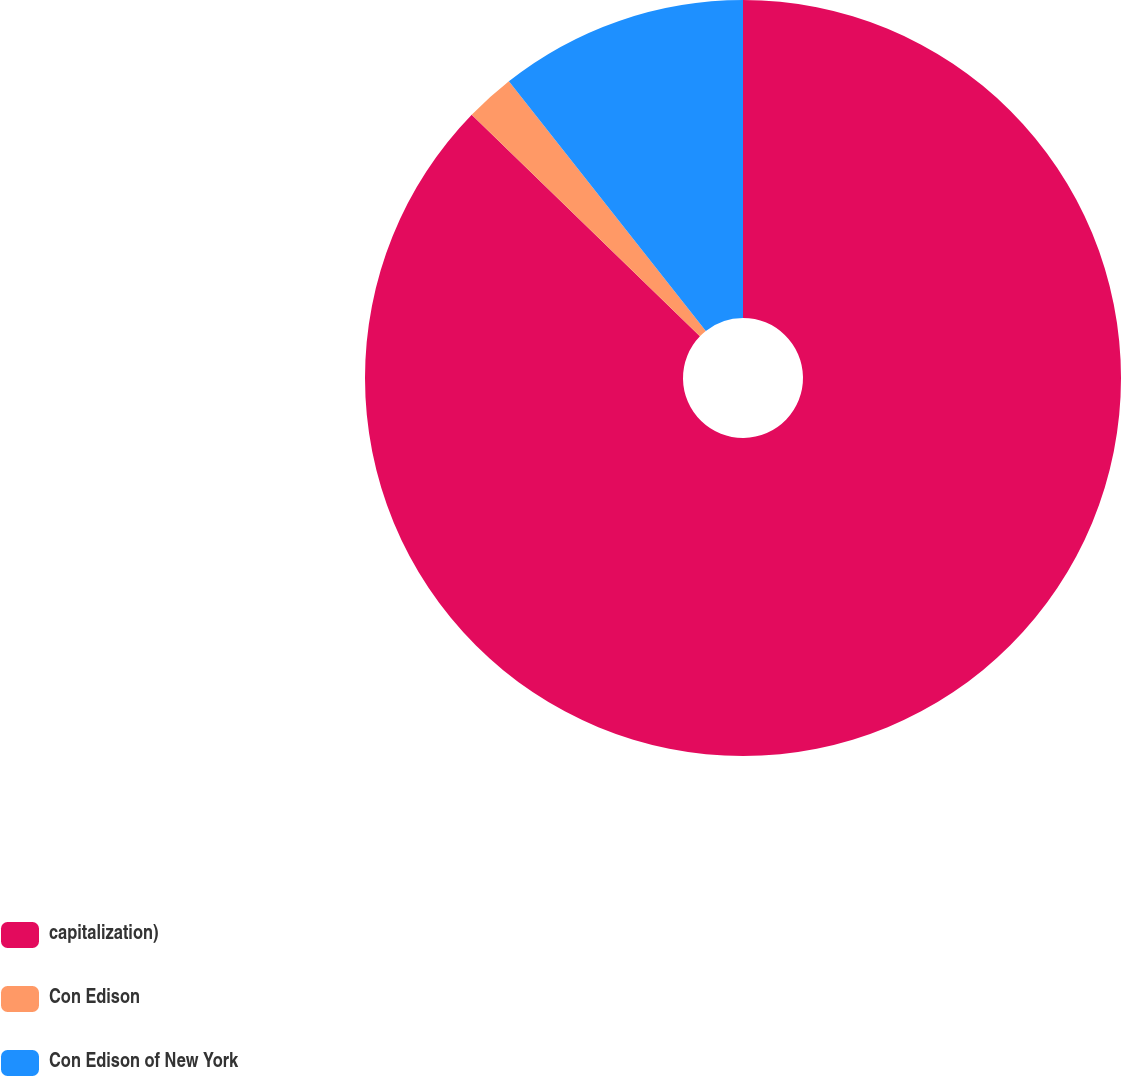Convert chart to OTSL. <chart><loc_0><loc_0><loc_500><loc_500><pie_chart><fcel>capitalization)<fcel>Con Edison<fcel>Con Edison of New York<nl><fcel>87.26%<fcel>2.11%<fcel>10.63%<nl></chart> 